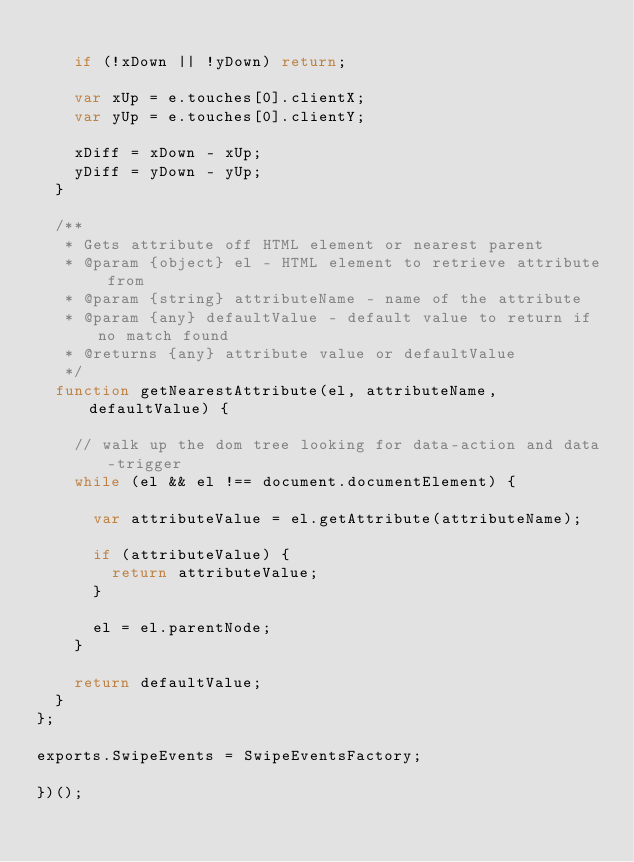<code> <loc_0><loc_0><loc_500><loc_500><_JavaScript_>
		if (!xDown || !yDown) return;

		var xUp = e.touches[0].clientX;
		var yUp = e.touches[0].clientY;

		xDiff = xDown - xUp;
		yDiff = yDown - yUp;
	}

	/**
	 * Gets attribute off HTML element or nearest parent
	 * @param {object} el - HTML element to retrieve attribute from
	 * @param {string} attributeName - name of the attribute
	 * @param {any} defaultValue - default value to return if no match found
	 * @returns {any} attribute value or defaultValue
	 */
	function getNearestAttribute(el, attributeName, defaultValue) {

		// walk up the dom tree looking for data-action and data-trigger
		while (el && el !== document.documentElement) {

			var attributeValue = el.getAttribute(attributeName);

			if (attributeValue) {
				return attributeValue;
			}

			el = el.parentNode;
		}

		return defaultValue;
	}
};

exports.SwipeEvents = SwipeEventsFactory;

})();</code> 